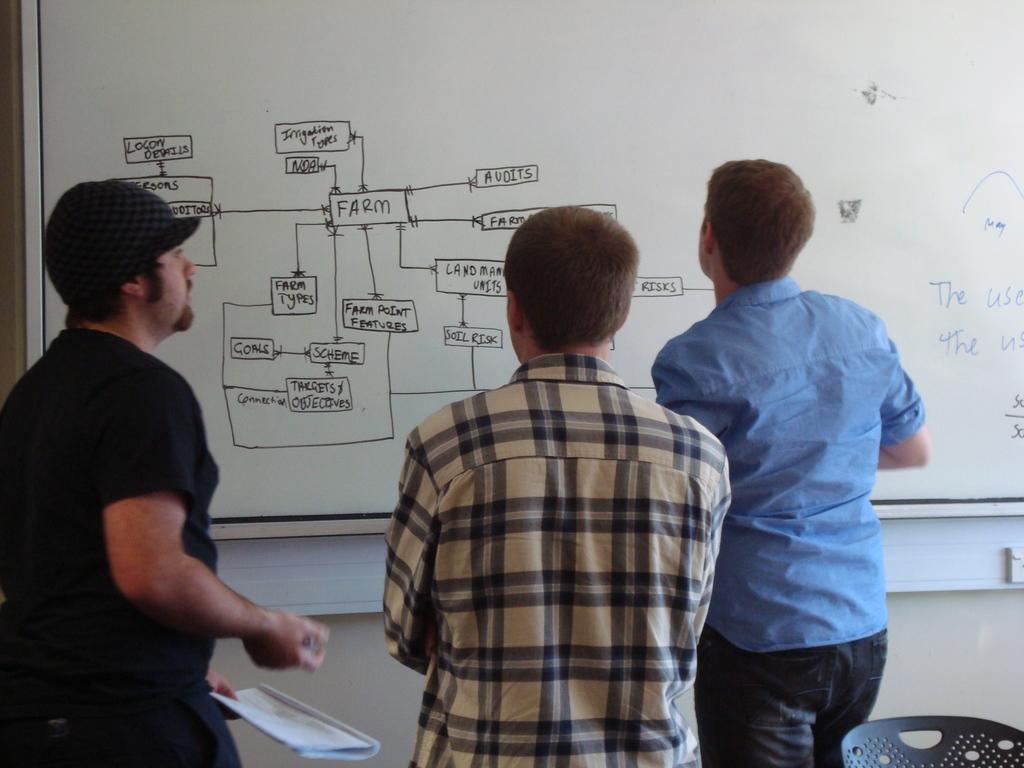What is the world written in blue that appears twice?
Your response must be concise. The. What is the 4 letter word in the box in the middle?
Offer a very short reply. Farm. 